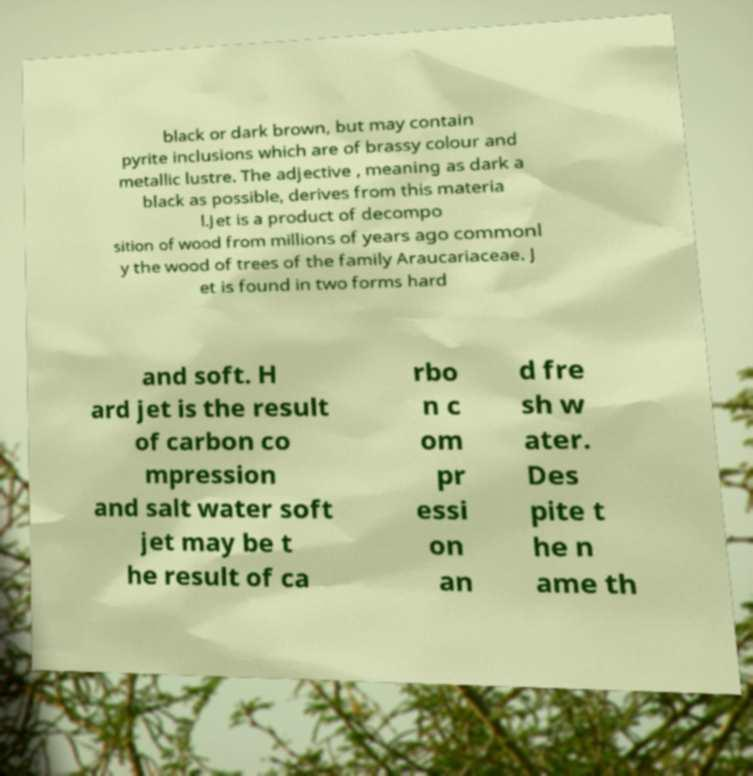I need the written content from this picture converted into text. Can you do that? black or dark brown, but may contain pyrite inclusions which are of brassy colour and metallic lustre. The adjective , meaning as dark a black as possible, derives from this materia l.Jet is a product of decompo sition of wood from millions of years ago commonl y the wood of trees of the family Araucariaceae. J et is found in two forms hard and soft. H ard jet is the result of carbon co mpression and salt water soft jet may be t he result of ca rbo n c om pr essi on an d fre sh w ater. Des pite t he n ame th 